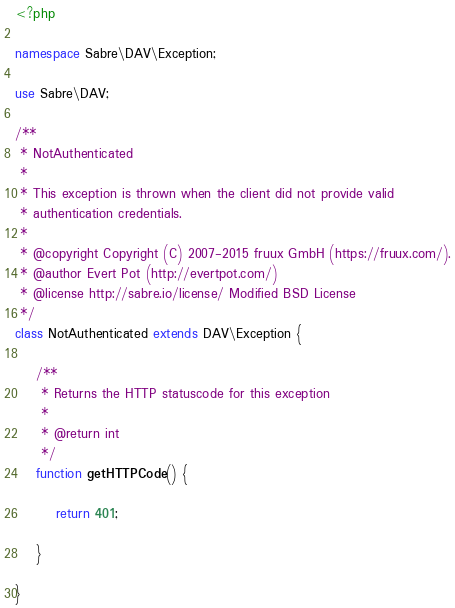<code> <loc_0><loc_0><loc_500><loc_500><_PHP_><?php

namespace Sabre\DAV\Exception;

use Sabre\DAV;

/**
 * NotAuthenticated
 *
 * This exception is thrown when the client did not provide valid
 * authentication credentials.
 *
 * @copyright Copyright (C) 2007-2015 fruux GmbH (https://fruux.com/).
 * @author Evert Pot (http://evertpot.com/)
 * @license http://sabre.io/license/ Modified BSD License
 */
class NotAuthenticated extends DAV\Exception {

    /**
     * Returns the HTTP statuscode for this exception
     *
     * @return int
     */
    function getHTTPCode() {

        return 401;

    }

}
</code> 